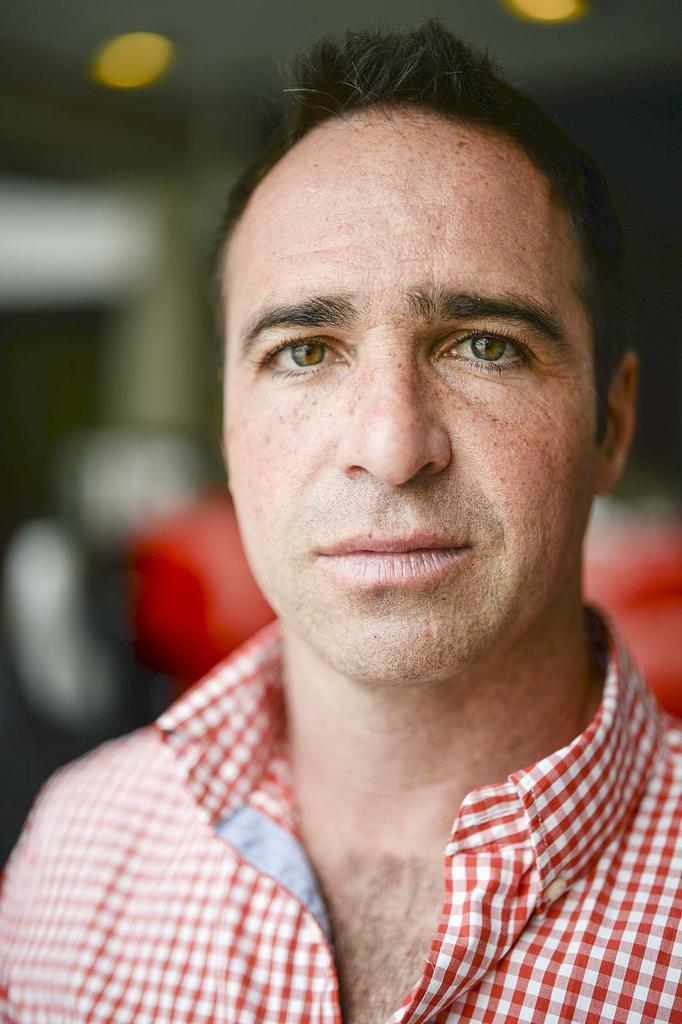What is the main subject of the image? There is a person in the image. Can you describe the background of the image? The background of the image is blurred. How many friends can be seen breathing in the image? There are no friends or breathing actions visible in the image, as it only features a person with a blurred background. 